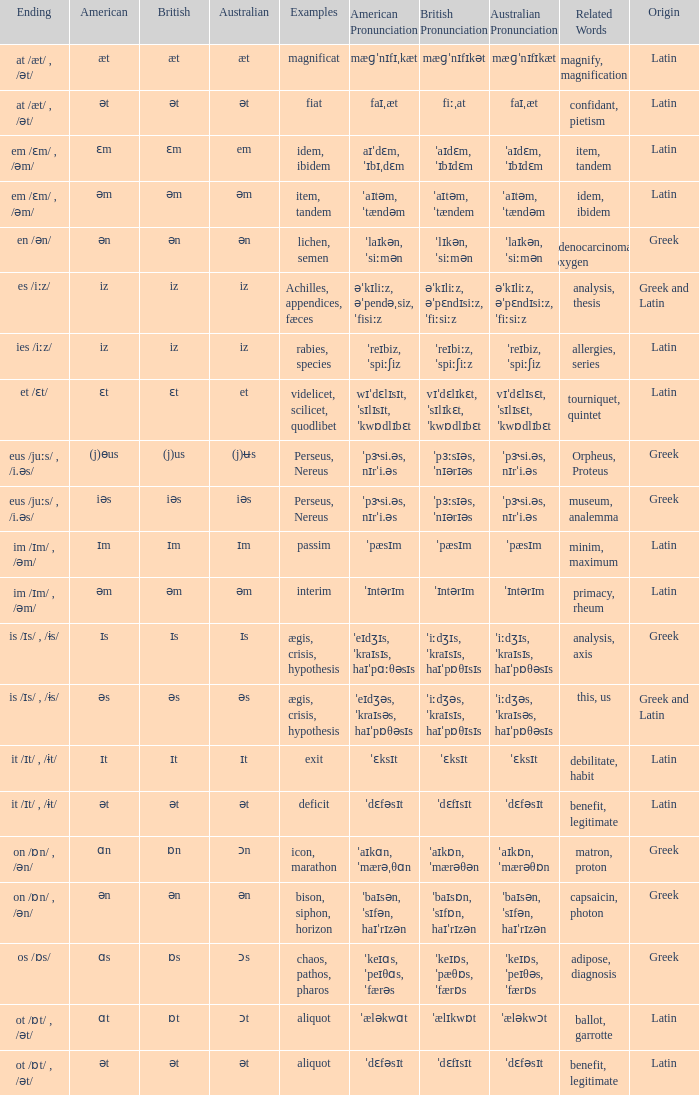Which British has Examples of exit? Ɪt. 